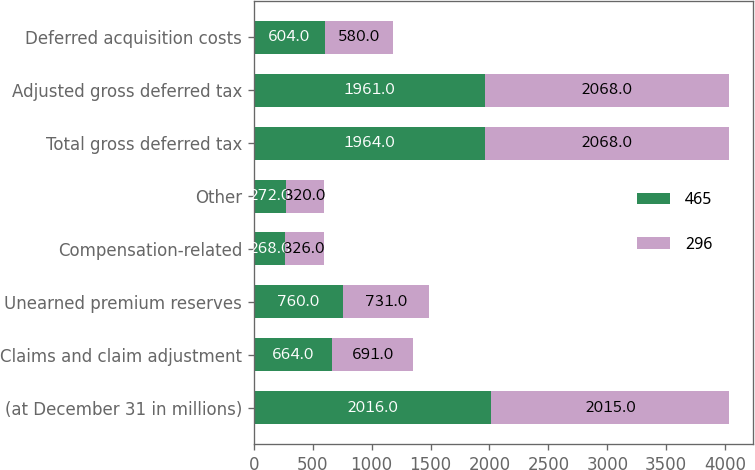<chart> <loc_0><loc_0><loc_500><loc_500><stacked_bar_chart><ecel><fcel>(at December 31 in millions)<fcel>Claims and claim adjustment<fcel>Unearned premium reserves<fcel>Compensation-related<fcel>Other<fcel>Total gross deferred tax<fcel>Adjusted gross deferred tax<fcel>Deferred acquisition costs<nl><fcel>465<fcel>2016<fcel>664<fcel>760<fcel>268<fcel>272<fcel>1964<fcel>1961<fcel>604<nl><fcel>296<fcel>2015<fcel>691<fcel>731<fcel>326<fcel>320<fcel>2068<fcel>2068<fcel>580<nl></chart> 